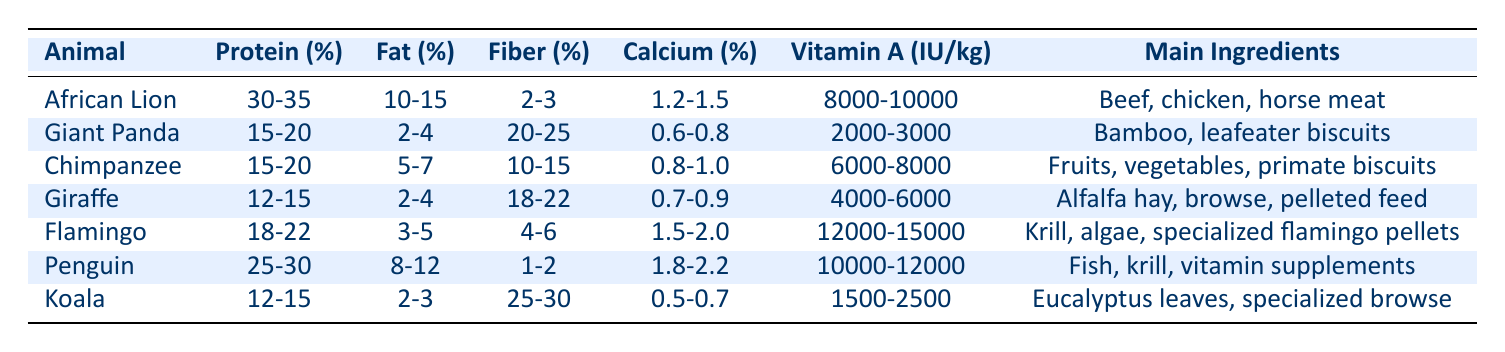What is the protein percentage range for an African Lion? The table lists the protein percentage for an African Lion as "30-35". To find the specific answer, I simply refer to the corresponding row under the "Protein (%)" column for the African Lion.
Answer: 30-35 What are the main ingredients of a Giraffe's diet? The diet of a Giraffe consists of "Alfalfa hay, browse, pelleted feed". This can be found in the "Main Ingredients" column for Giraffe in the table.
Answer: Alfalfa hay, browse, pelleted feed Which animal has the highest fat percentage in its diet? To find the animal with the highest fat percentage, I look through the "Fat (%)" column and identify the values: African Lion (10-15), Giant Panda (2-4), Chimpanzee (5-7), Giraffe (2-4), Flamingo (3-5), Penguin (8-12), and Koala (2-3). The African Lion has the highest fat percentage range of "10-15".
Answer: African Lion What is the average fiber percentage for a Penguin and a Giraffe? The fiber percentage for a Penguin is "1-2" and for Giraffe is "18-22". To calculate the average, I find the midpoint: Penguin (1.5) and Giraffe (20) and then sum those values: (1.5 + 20) / 2 = 10.75.
Answer: 10.75 Is the Vitamin A content for a Koala higher than that of a Giant Panda? The Vitamin A content is "1500-2500" IU/kg for Koala and "2000-3000" IU/kg for Giant Panda. Since the lower limit of Koala (1500) is less than the lower limit of Giant Panda (2000), the claim is false.
Answer: No Which animal has the least fiber in their diet? Inspecting the "Fiber (%)" column shows that the Penguin has a range of "1-2", which is less than the other animals' fiber percentages. After checking all the values, the Penguin indeed has the least fiber percentage.
Answer: Penguin How much calcium does a Flamingo's diet contain? For the Flamingo, the calcium percentage is "1.5-2.0". I can find this by looking at the "Calcium (%)" column for the Flamingo row in the table.
Answer: 1.5-2.0 Which animal's diet contains the most Vitamin A? By examining the "Vitamin A (IU/kg)" column, I note the values: African Lion (8000-10000), Giant Panda (2000-3000), Chimpanzee (6000-8000), Giraffe (4000-6000), Flamingo (12000-15000), Penguin (10000-12000), and Koala (1500-2500). The Flamingo has the highest range of "12000-15000".
Answer: Flamingo Does a Giraffe's diet contain more protein than a Chimpanzee's? The protein percentage for Giraffe is "12-15" while for Chimpanzee it is "15-20". Since the maximum protein for Chimpanzee (20) is greater than the maximum protein for Giraffe (15), the statement is false.
Answer: No 